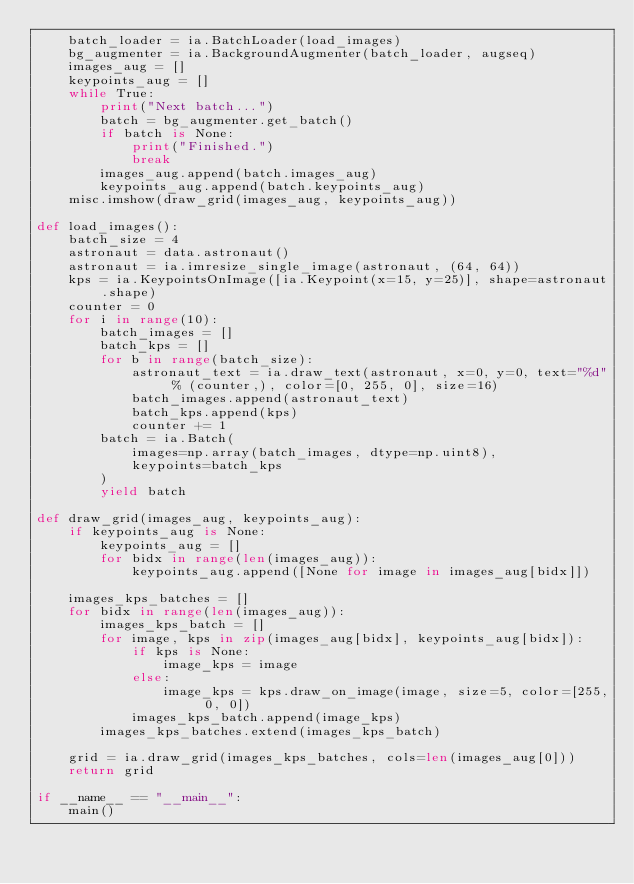<code> <loc_0><loc_0><loc_500><loc_500><_Python_>    batch_loader = ia.BatchLoader(load_images)
    bg_augmenter = ia.BackgroundAugmenter(batch_loader, augseq)
    images_aug = []
    keypoints_aug = []
    while True:
        print("Next batch...")
        batch = bg_augmenter.get_batch()
        if batch is None:
            print("Finished.")
            break
        images_aug.append(batch.images_aug)
        keypoints_aug.append(batch.keypoints_aug)
    misc.imshow(draw_grid(images_aug, keypoints_aug))

def load_images():
    batch_size = 4
    astronaut = data.astronaut()
    astronaut = ia.imresize_single_image(astronaut, (64, 64))
    kps = ia.KeypointsOnImage([ia.Keypoint(x=15, y=25)], shape=astronaut.shape)
    counter = 0
    for i in range(10):
        batch_images = []
        batch_kps = []
        for b in range(batch_size):
            astronaut_text = ia.draw_text(astronaut, x=0, y=0, text="%d" % (counter,), color=[0, 255, 0], size=16)
            batch_images.append(astronaut_text)
            batch_kps.append(kps)
            counter += 1
        batch = ia.Batch(
            images=np.array(batch_images, dtype=np.uint8),
            keypoints=batch_kps
        )
        yield batch

def draw_grid(images_aug, keypoints_aug):
    if keypoints_aug is None:
        keypoints_aug = []
        for bidx in range(len(images_aug)):
            keypoints_aug.append([None for image in images_aug[bidx]])

    images_kps_batches = []
    for bidx in range(len(images_aug)):
        images_kps_batch = []
        for image, kps in zip(images_aug[bidx], keypoints_aug[bidx]):
            if kps is None:
                image_kps = image
            else:
                image_kps = kps.draw_on_image(image, size=5, color=[255, 0, 0])
            images_kps_batch.append(image_kps)
        images_kps_batches.extend(images_kps_batch)

    grid = ia.draw_grid(images_kps_batches, cols=len(images_aug[0]))
    return grid

if __name__ == "__main__":
    main()
</code> 